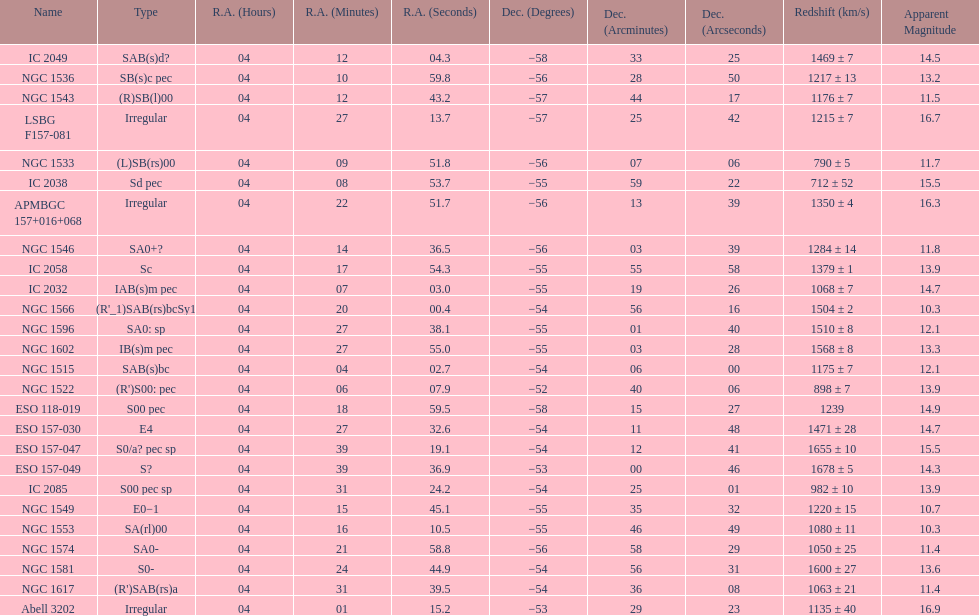Name the member with the highest apparent magnitude. Abell 3202. 